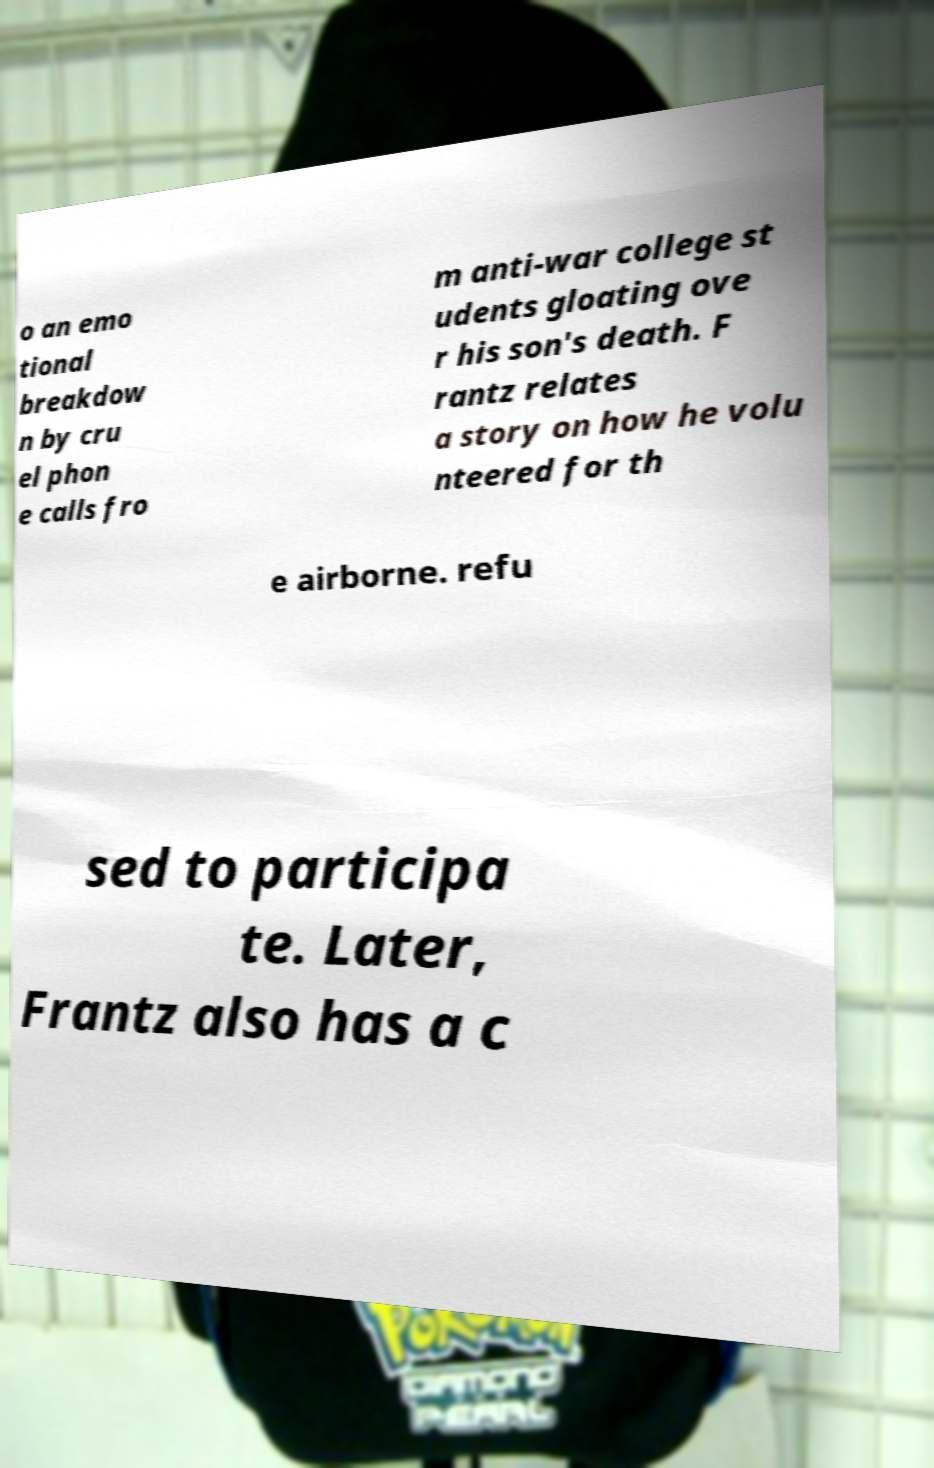Please identify and transcribe the text found in this image. o an emo tional breakdow n by cru el phon e calls fro m anti-war college st udents gloating ove r his son's death. F rantz relates a story on how he volu nteered for th e airborne. refu sed to participa te. Later, Frantz also has a c 